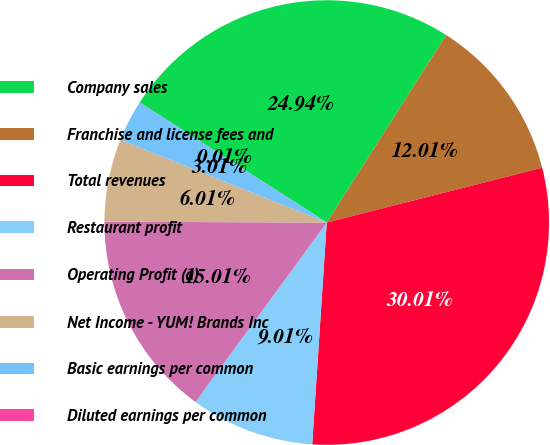<chart> <loc_0><loc_0><loc_500><loc_500><pie_chart><fcel>Company sales<fcel>Franchise and license fees and<fcel>Total revenues<fcel>Restaurant profit<fcel>Operating Profit (a)<fcel>Net Income - YUM! Brands Inc<fcel>Basic earnings per common<fcel>Diluted earnings per common<nl><fcel>24.94%<fcel>12.01%<fcel>30.01%<fcel>9.01%<fcel>15.01%<fcel>6.01%<fcel>3.01%<fcel>0.01%<nl></chart> 